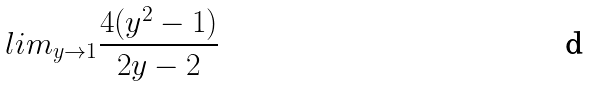<formula> <loc_0><loc_0><loc_500><loc_500>l i m _ { y \rightarrow 1 } \frac { 4 ( y ^ { 2 } - 1 ) } { 2 y - 2 }</formula> 